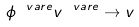Convert formula to latex. <formula><loc_0><loc_0><loc_500><loc_500>\phi ^ { \ v a r e } v ^ { \ v a r e } \rightarrow v</formula> 